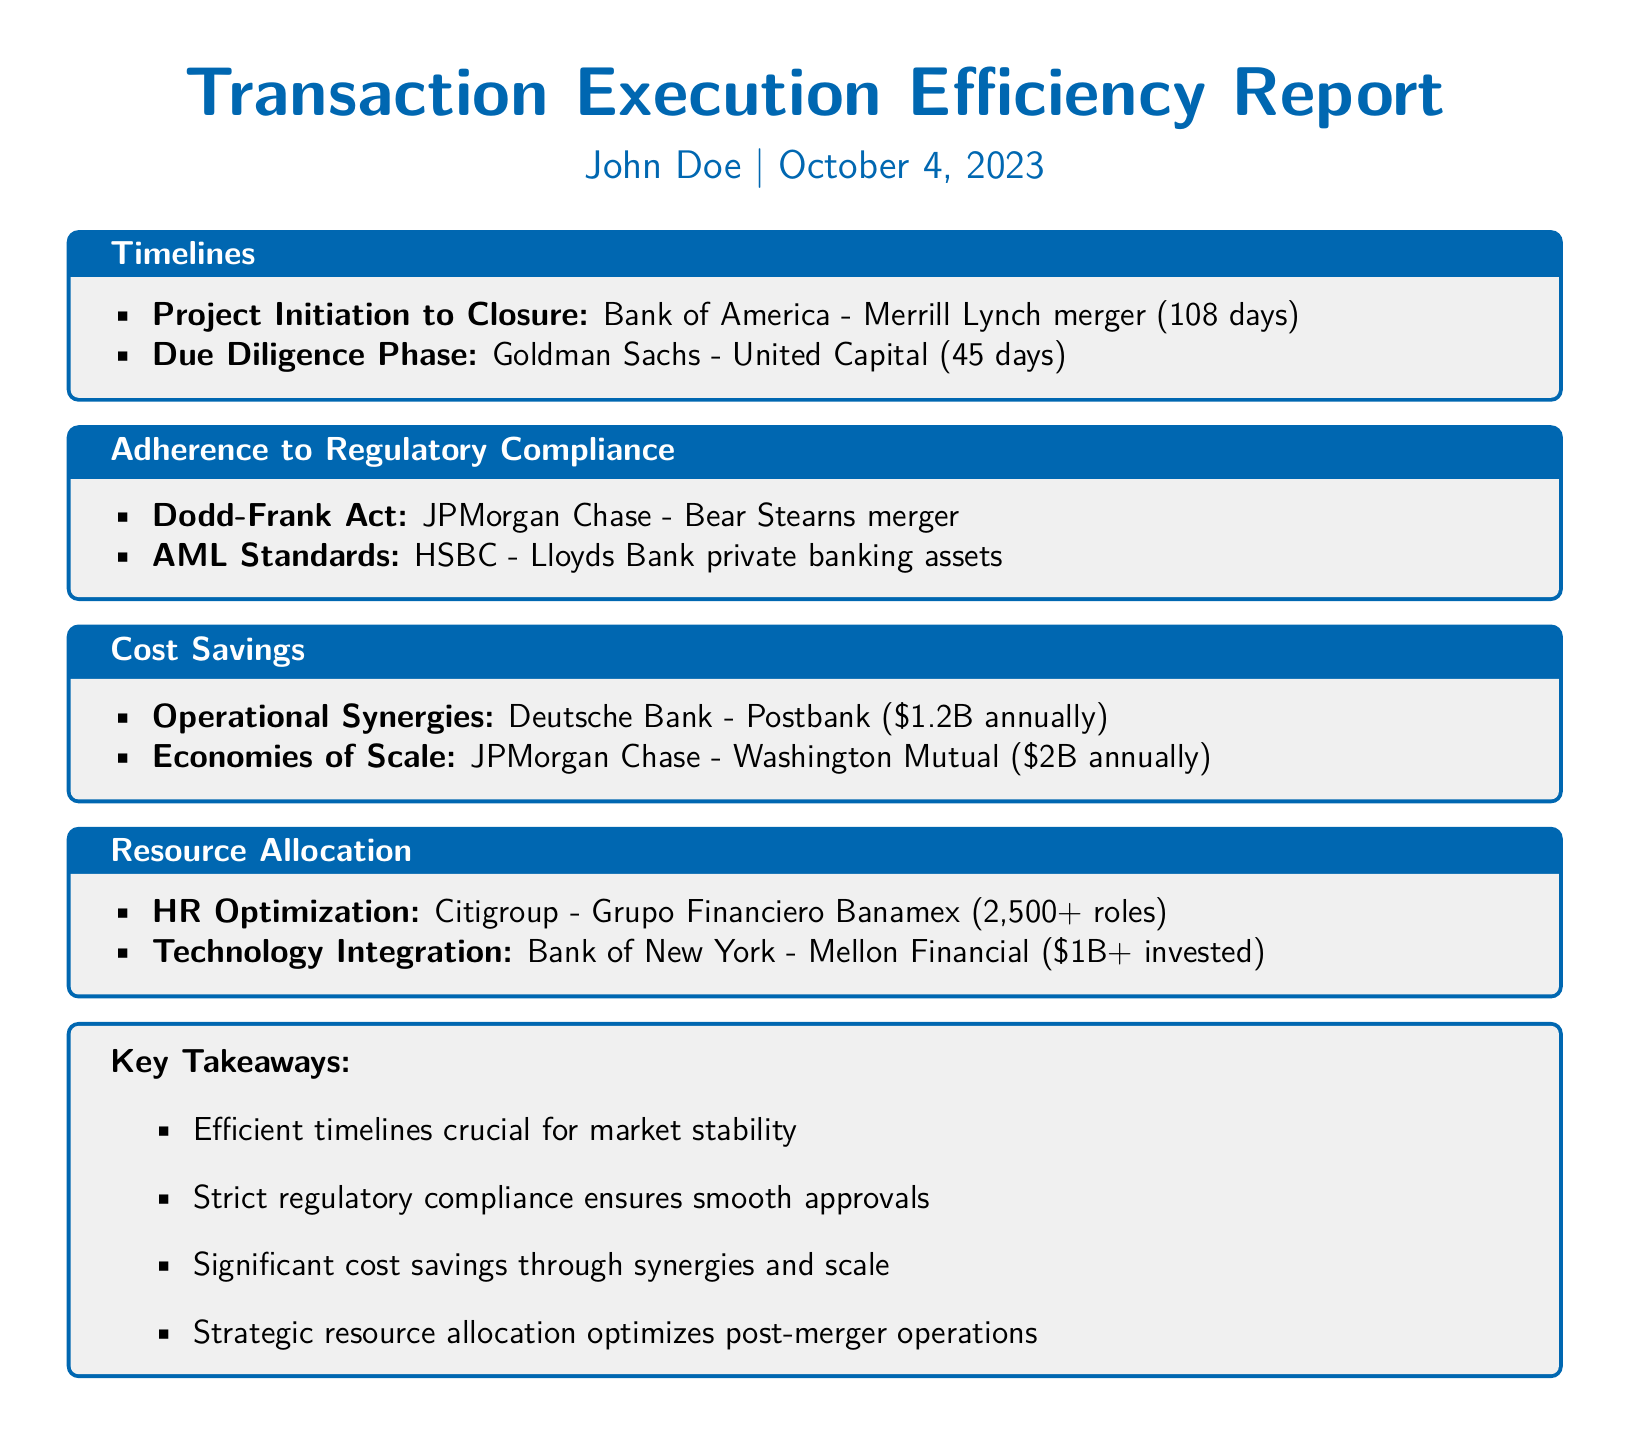What is the duration from initiation to closure for the Bank of America - Merrill Lynch merger? The duration from initiation to closure for this merger is stated in the Timelines section of the document.
Answer: 108 days What was the duration of the due diligence phase for the Goldman Sachs - United Capital? The duration is specified under the Timelines section.
Answer: 45 days Which merger adhered to the Dodd-Frank Act? The document lists this merger within the Adherence to Regulatory Compliance section.
Answer: JPMorgan Chase - Bear Stearns What are the operational synergies achieved from the Deutsche Bank - Postbank merger? The cost savings from this merger are highlighted in the Cost Savings section.
Answer: $1.2B annually How many roles were optimized in the HR for the Citigroup - Grupo Financiero Banamex merger? This information is provided under the Resource Allocation section.
Answer: 2,500+ What is the amount invested in technology integration for the Bank of New York - Mellon Financial merger? This cost is listed in the Resource Allocation section.
Answer: $1B+ What key takeaway emphasizes regulatory compliance? The Key Takeaways section summarizes crucial insights from the report.
Answer: Strict regulatory compliance ensures smooth approvals What are the economies of scale for the JPMorgan Chase - Washington Mutual merger? This financial benefit is mentioned in the Cost Savings section of the report.
Answer: $2B annually 